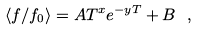Convert formula to latex. <formula><loc_0><loc_0><loc_500><loc_500>\langle f / f _ { 0 } \rangle = A T ^ { x } e ^ { - y T } + B \ ,</formula> 